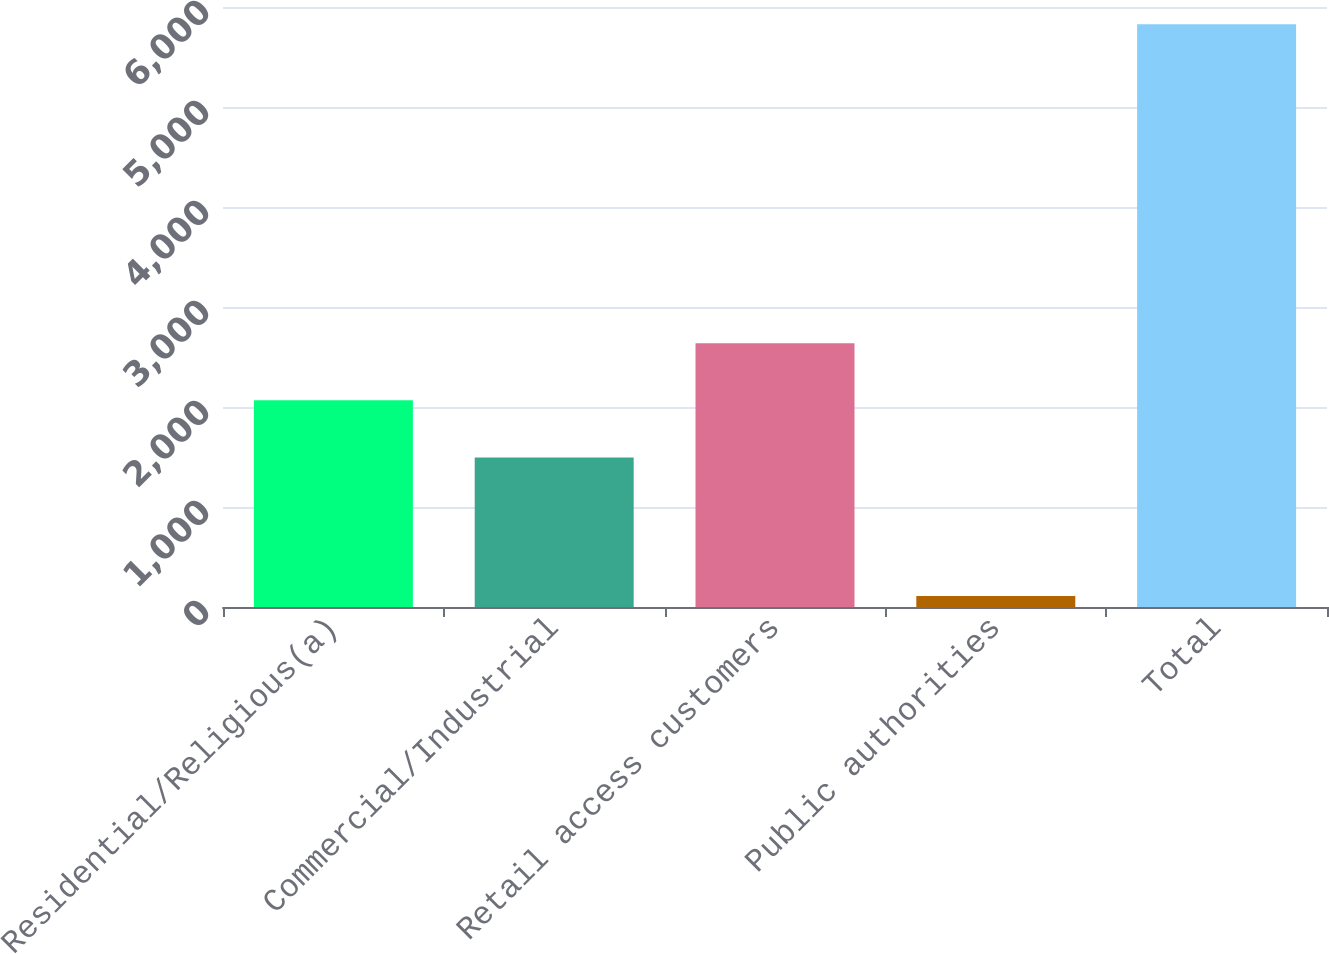Convert chart to OTSL. <chart><loc_0><loc_0><loc_500><loc_500><bar_chart><fcel>Residential/Religious(a)<fcel>Commercial/Industrial<fcel>Retail access customers<fcel>Public authorities<fcel>Total<nl><fcel>2066.8<fcel>1495<fcel>2638.6<fcel>110<fcel>5828<nl></chart> 